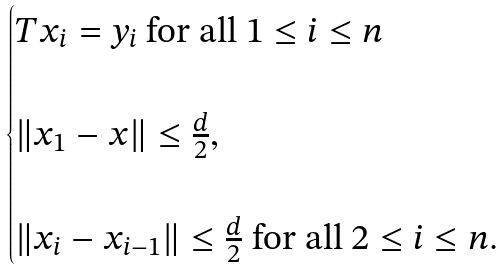Convert formula to latex. <formula><loc_0><loc_0><loc_500><loc_500>\begin{cases} T x _ { i } = y _ { i } \text { for all } 1 \leq i \leq n \\ \\ \| x _ { 1 } - x \| \leq \frac { d } { 2 } , \\ \\ \| x _ { i } - x _ { i - 1 } \| \leq \frac { d } { 2 } \text { for all } 2 \leq i \leq n . \\ \end{cases}</formula> 